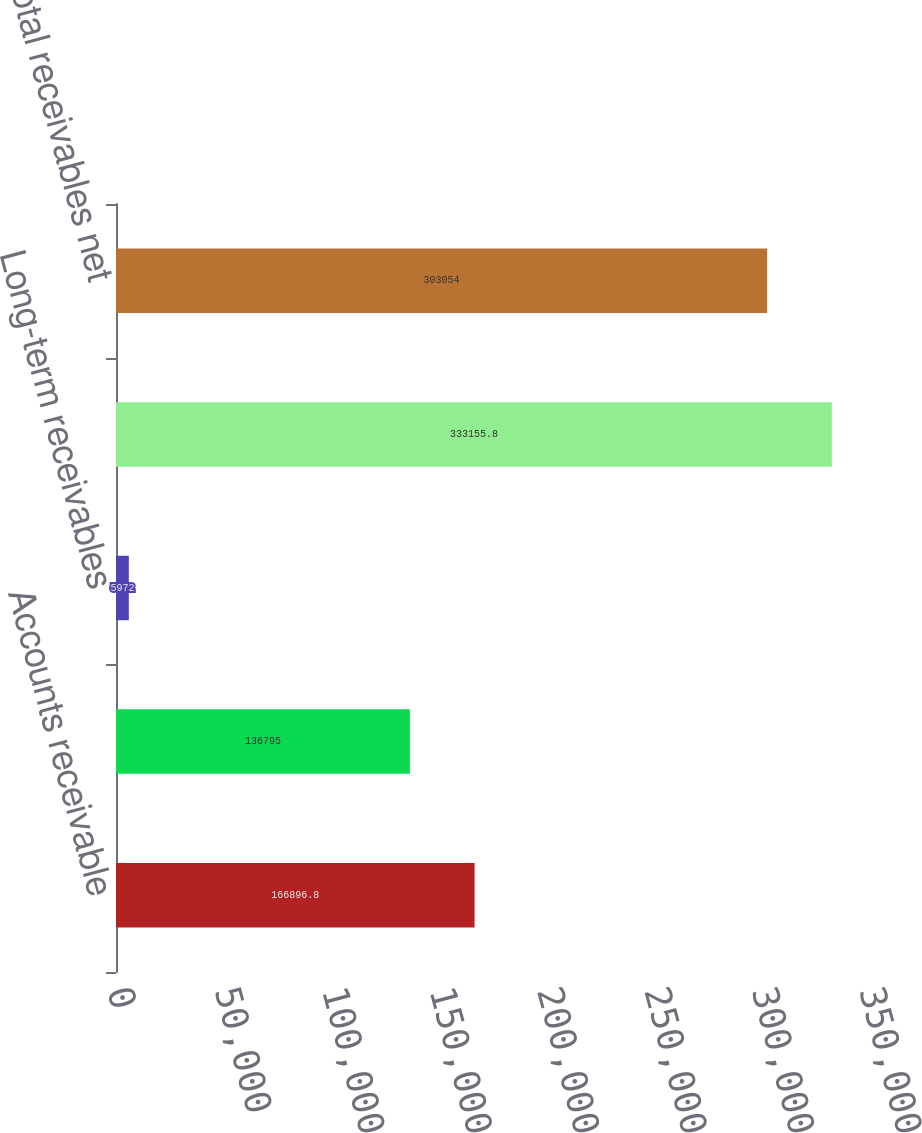<chart> <loc_0><loc_0><loc_500><loc_500><bar_chart><fcel>Accounts receivable<fcel>Unbilled accounts receivable<fcel>Long-term receivables<fcel>Total receivables<fcel>Total receivables net<nl><fcel>166897<fcel>136795<fcel>5972<fcel>333156<fcel>303054<nl></chart> 